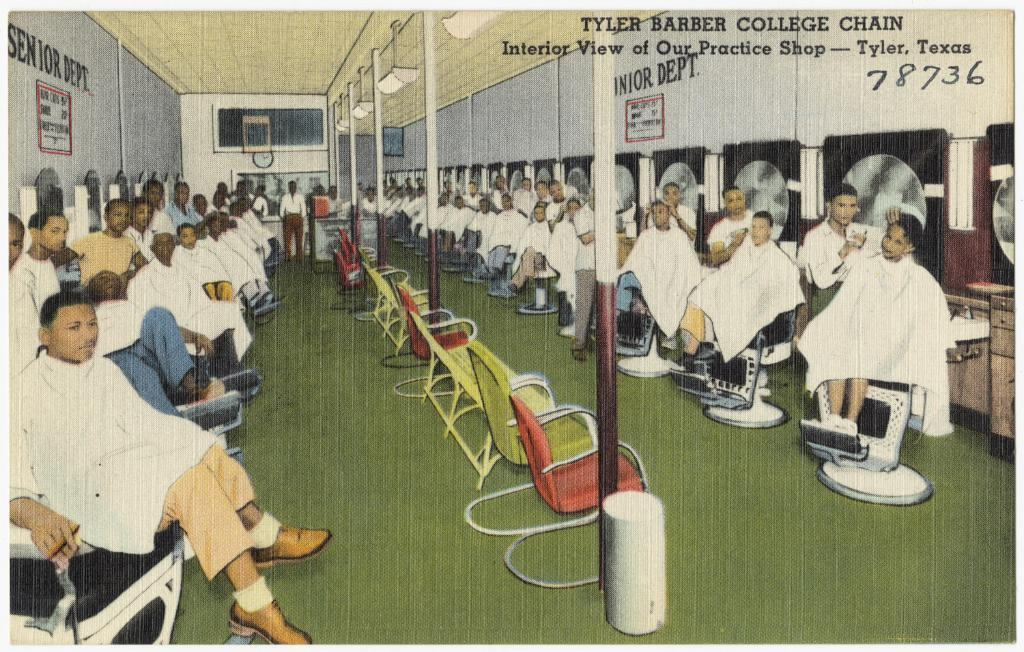How many people are in the image? There is a group of people in the image. What are the people doing in the image? The people are sitting on chairs. What objects can be seen in the image besides the people? Poles, posters, a clock on the wall, and objects in the background are visible in the image. What can be seen on the wall in the image? There is a clock on the wall. What is present in the background of the image? In the background, there is a man standing, and there are objects and text visible. What type of spade is being used by the people in the image? There is no spade present in the image; the people are sitting on chairs. How many birds are in the flock that is visible in the image? There is no flock of birds present in the image; the image features a group of people sitting on chairs. 